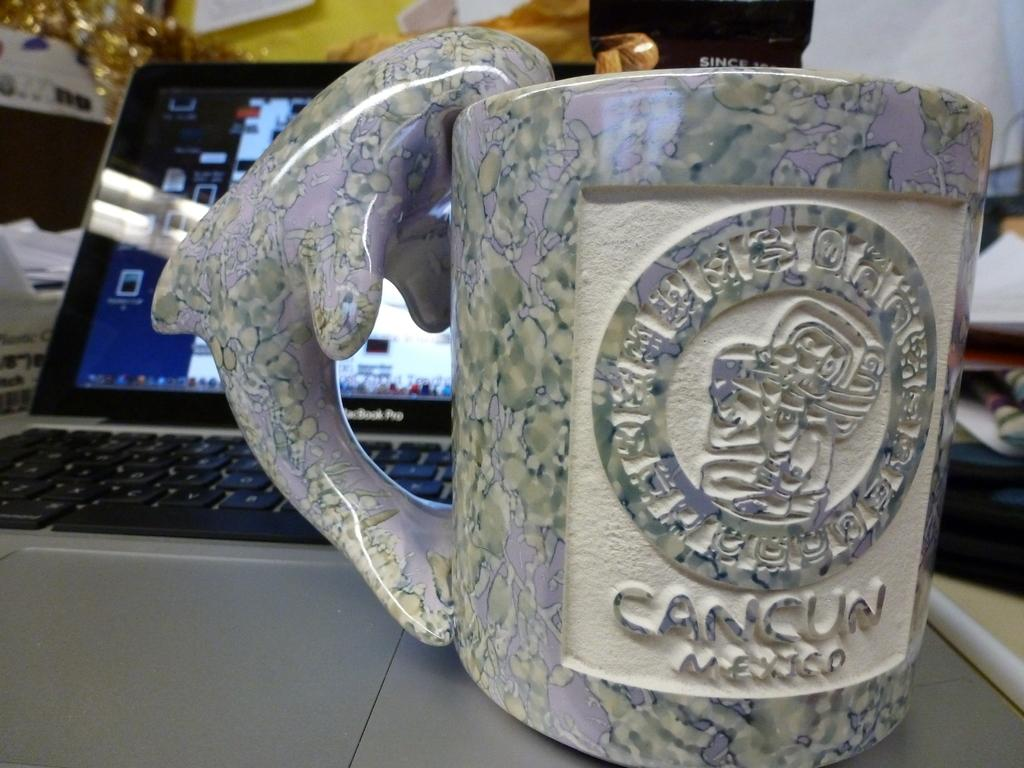<image>
Create a compact narrative representing the image presented. a fancy marble mug from Cancun Mexico with an ornate design sits on a computer 